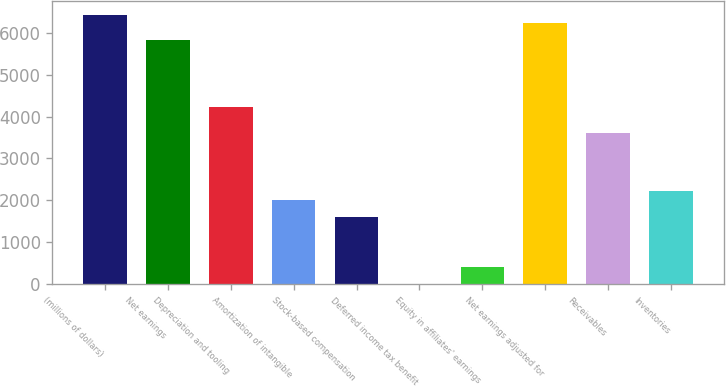Convert chart to OTSL. <chart><loc_0><loc_0><loc_500><loc_500><bar_chart><fcel>(millions of dollars)<fcel>Net earnings<fcel>Depreciation and tooling<fcel>Amortization of intangible<fcel>Stock-based compensation<fcel>Deferred income tax benefit<fcel>Equity in affiliates' earnings<fcel>Net earnings adjusted for<fcel>Receivables<fcel>Inventories<nl><fcel>6432.78<fcel>5829.81<fcel>4221.89<fcel>2011<fcel>1609.02<fcel>1.1<fcel>403.08<fcel>6231.79<fcel>3618.92<fcel>2211.99<nl></chart> 